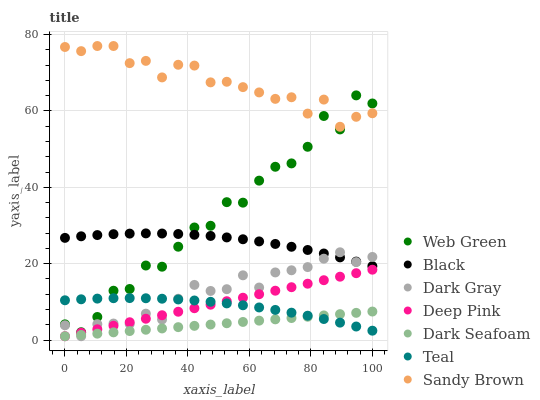Does Dark Seafoam have the minimum area under the curve?
Answer yes or no. Yes. Does Sandy Brown have the maximum area under the curve?
Answer yes or no. Yes. Does Web Green have the minimum area under the curve?
Answer yes or no. No. Does Web Green have the maximum area under the curve?
Answer yes or no. No. Is Dark Seafoam the smoothest?
Answer yes or no. Yes. Is Web Green the roughest?
Answer yes or no. Yes. Is Dark Gray the smoothest?
Answer yes or no. No. Is Dark Gray the roughest?
Answer yes or no. No. Does Deep Pink have the lowest value?
Answer yes or no. Yes. Does Web Green have the lowest value?
Answer yes or no. No. Does Sandy Brown have the highest value?
Answer yes or no. Yes. Does Web Green have the highest value?
Answer yes or no. No. Is Teal less than Black?
Answer yes or no. Yes. Is Sandy Brown greater than Deep Pink?
Answer yes or no. Yes. Does Deep Pink intersect Dark Seafoam?
Answer yes or no. Yes. Is Deep Pink less than Dark Seafoam?
Answer yes or no. No. Is Deep Pink greater than Dark Seafoam?
Answer yes or no. No. Does Teal intersect Black?
Answer yes or no. No. 